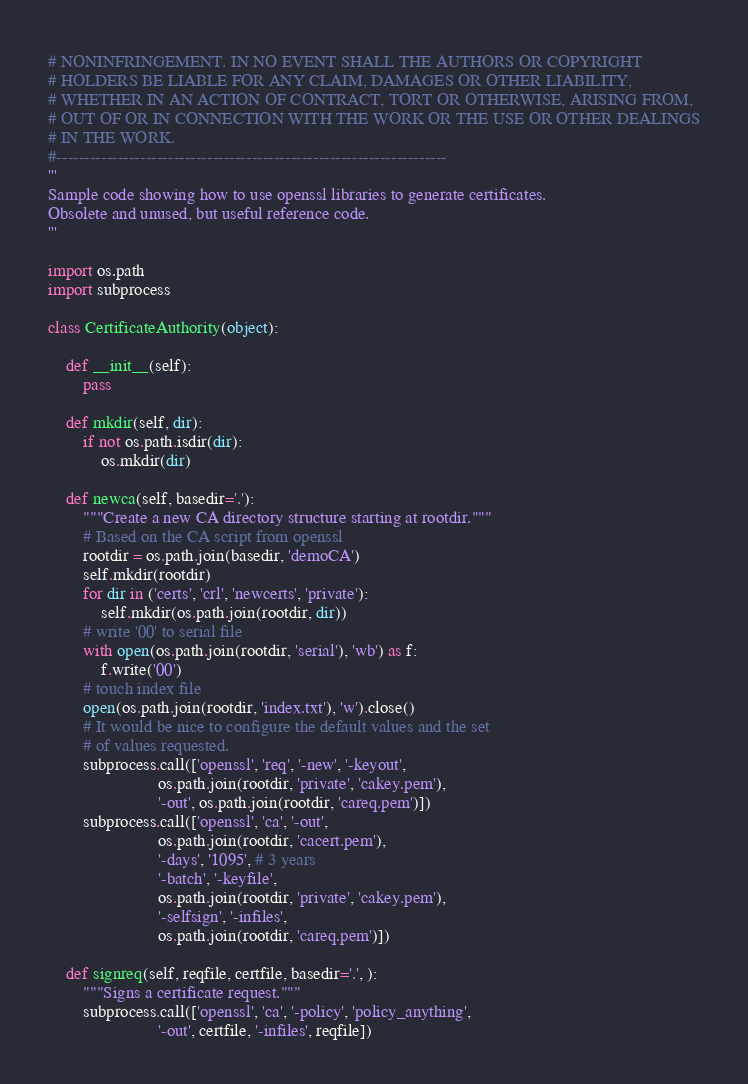Convert code to text. <code><loc_0><loc_0><loc_500><loc_500><_Python_># NONINFRINGEMENT. IN NO EVENT SHALL THE AUTHORS OR COPYRIGHT
# HOLDERS BE LIABLE FOR ANY CLAIM, DAMAGES OR OTHER LIABILITY,
# WHETHER IN AN ACTION OF CONTRACT, TORT OR OTHERWISE, ARISING FROM,
# OUT OF OR IN CONNECTION WITH THE WORK OR THE USE OR OTHER DEALINGS
# IN THE WORK.
#----------------------------------------------------------------------
'''
Sample code showing how to use openssl libraries to generate certificates.
Obsolete and unused, but useful reference code.
'''

import os.path
import subprocess

class CertificateAuthority(object):

    def __init__(self):
        pass

    def mkdir(self, dir):
        if not os.path.isdir(dir):
            os.mkdir(dir)

    def newca(self, basedir='.'):
        """Create a new CA directory structure starting at rootdir."""
        # Based on the CA script from openssl
        rootdir = os.path.join(basedir, 'demoCA')
        self.mkdir(rootdir)
        for dir in ('certs', 'crl', 'newcerts', 'private'):
            self.mkdir(os.path.join(rootdir, dir))
        # write '00' to serial file
        with open(os.path.join(rootdir, 'serial'), 'wb') as f:
            f.write('00')
        # touch index file
        open(os.path.join(rootdir, 'index.txt'), 'w').close()
        # It would be nice to configure the default values and the set
        # of values requested.
        subprocess.call(['openssl', 'req', '-new', '-keyout',
                         os.path.join(rootdir, 'private', 'cakey.pem'),
                         '-out', os.path.join(rootdir, 'careq.pem')])
        subprocess.call(['openssl', 'ca', '-out', 
                         os.path.join(rootdir, 'cacert.pem'),
                         '-days', '1095', # 3 years
                         '-batch', '-keyfile',
                         os.path.join(rootdir, 'private', 'cakey.pem'),
                         '-selfsign', '-infiles', 
                         os.path.join(rootdir, 'careq.pem')])

    def signreq(self, reqfile, certfile, basedir='.', ):
        """Signs a certificate request."""
        subprocess.call(['openssl', 'ca', '-policy', 'policy_anything',
                         '-out', certfile, '-infiles', reqfile])
</code> 